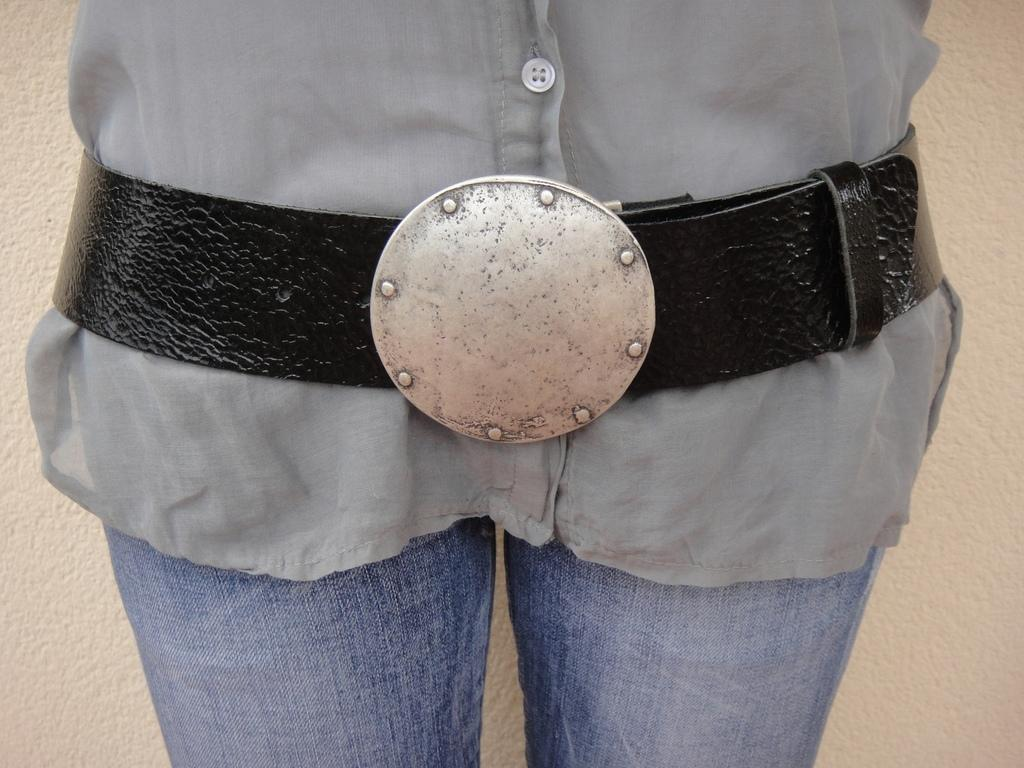What is the main subject of the image? There is a person in the image. What color is the shirt the person is wearing? The person is wearing a grey shirt. What type of pants is the person wearing? The person is wearing blue jeans. What accessory is the person wearing around their waist? The person is wearing a black belt. What color is the background of the image? The background of the image is cream colored. Can you see any ants crawling on the person's shirt in the image? There are no ants visible in the image. What type of sky is depicted in the image? The image does not show a sky; it focuses on the person and their clothing. 